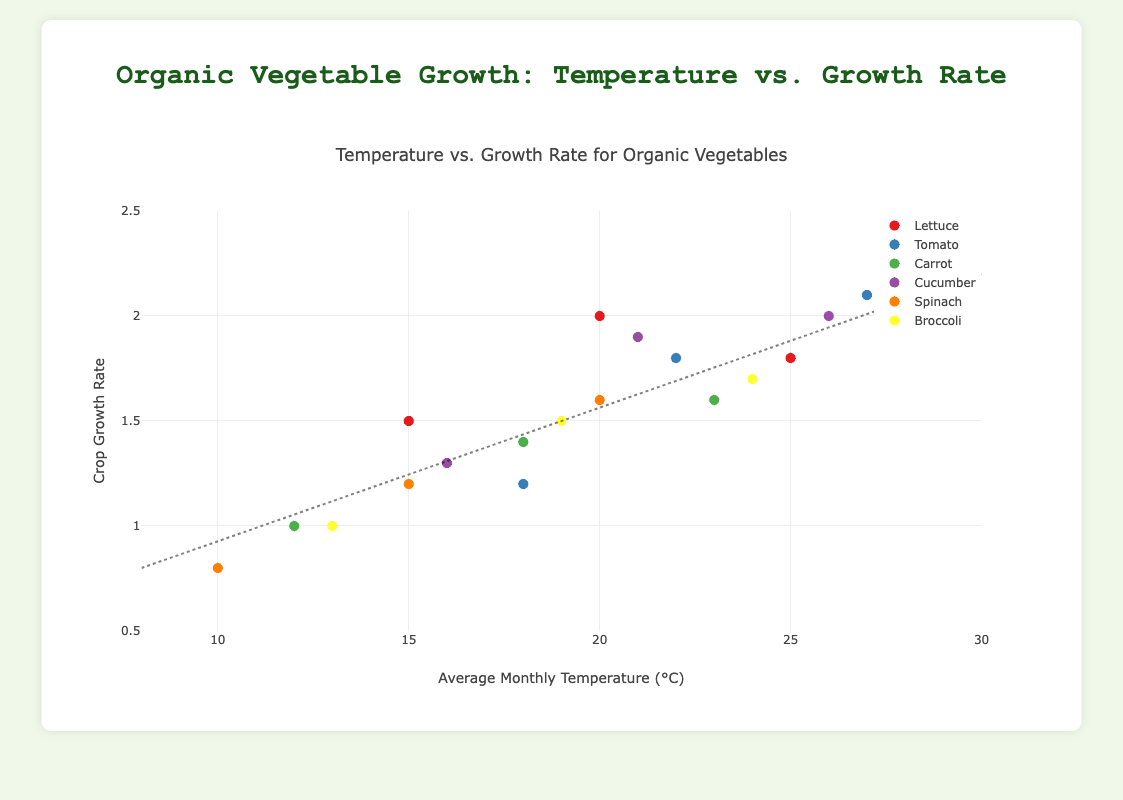What is the title of the chart? The title is displayed at the top center of the chart, reading "Temperature vs. Growth Rate for Organic Vegetables".
Answer: Temperature vs. Growth Rate for Organic Vegetables What are the ranges of the X and Y axes? The X-axis (Average Monthly Temperature) ranges from 8 to 30 degrees Celsius, and the Y-axis (Crop Growth Rate) ranges from 0.5 to 2.5. These ranges can be observed from the axis labels and the tick marks on the plot.
Answer: X-axis: 8 to 30, Y-axis: 0.5 to 2.5 How does the growth rate of Tomatoes compare to that of Lettuce at 20°C? At 20°C, the growth rate for Tomatoes is around 1.8, while for Lettuce, it is higher at 2.0. This can be determined by locating the data points for both vegetables at the 20°C mark on the X-axis and comparing their Y-axis values.
Answer: Lettuce has a higher growth rate Which vegetable shows the highest growth rate, and at what temperature? The vegetable data points show that Tomatoes exhibit the highest growth rate of 2.1 at 27°C. This is seen by observing the highest data point on the Y-axis and matching it with the corresponding vegetable and temperature on the X-axis.
Answer: Tomato at 27°C Is there a general trend observed between temperature and crop growth rate in the trend line? The trend line generally ascends from lower left to upper right, indicating that as the temperature increases, the crop growth rate also tends to increase. This upward trajectory can be inferred from the line shape that spans from 8°C and 0.8 growth rate to 30°C and 2.2 growth rate.
Answer: Increasing trend Between which temperatures does Broccoli show the most significant growth rate increase? Broccoli shows the most significant growth rate increase between 13°C and 19°C, where the growth rate goes from 1.0 to 1.5. This can be seen by comparing the Broccoli data points on the X-axis and observing the change in corresponding Y-axis values.
Answer: 13°C to 19°C Which vegetable shows the smallest change in growth rate across different temperatures? Lettuce's growth rate changes the least across different temperatures, ranging from 1.5 to 2.0 as temperatures go from 15°C to 25°C. This small variation can be observed by examining the spaced-out points for Lettuce on the chart.
Answer: Lettuce What's the combined number of data points for Cucumber and Spinach? Cucumber has three data points, and Spinach also has three. Adding these gives the combined total number of data points as 3 (Cucumber) + 3 (Spinach) = 6. This can be counted directly from the number of points for each vegetable on the chart.
Answer: 6 Which vegetable has the most uniform growth rate increment as the temperature rises? Carrot has the most uniform growth rate increment, as it rises steadily from 1.0 at 12°C to 1.4 at 18°C to 1.6 at 23°C. This uniformity is seen by the equal spacing of data points along both the X and Y axes.
Answer: Carrot 